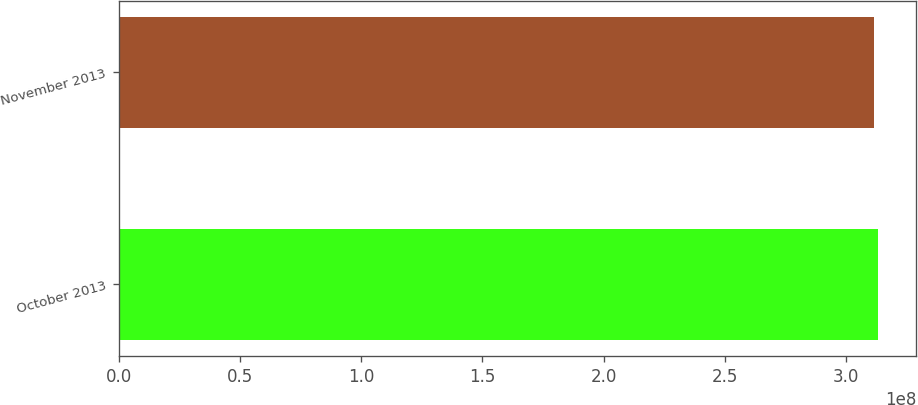<chart> <loc_0><loc_0><loc_500><loc_500><bar_chart><fcel>October 2013<fcel>November 2013<nl><fcel>3.13327e+08<fcel>3.11571e+08<nl></chart> 